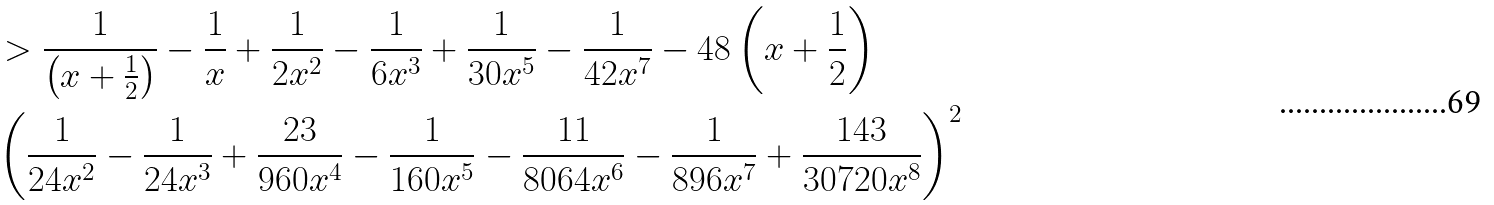Convert formula to latex. <formula><loc_0><loc_0><loc_500><loc_500>& > \frac { 1 } { \left ( x + \frac { 1 } { 2 } \right ) } - \frac { 1 } { x } + \frac { 1 } { 2 x ^ { 2 } } - \frac { 1 } { 6 x ^ { 3 } } + \frac { 1 } { 3 0 x ^ { 5 } } - \frac { 1 } { 4 2 x ^ { 7 } } - 4 8 \left ( x + \frac { 1 } { 2 } \right ) \\ & \left ( \frac { 1 } { 2 4 x ^ { 2 } } - \frac { 1 } { 2 4 x ^ { 3 } } + \frac { 2 3 } { 9 6 0 x ^ { 4 } } - \frac { 1 } { 1 6 0 x ^ { 5 } } - \frac { 1 1 } { 8 0 6 4 x ^ { 6 } } - \frac { 1 } { 8 9 6 x ^ { 7 } } + \frac { 1 4 3 } { 3 0 7 2 0 x ^ { 8 } } \right ) ^ { 2 } \\</formula> 